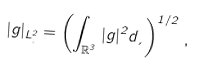Convert formula to latex. <formula><loc_0><loc_0><loc_500><loc_500>| g | _ { L _ { \xi } ^ { 2 } } = \left ( \int _ { { \mathbb { R } } ^ { 3 } } | g | ^ { 2 } d \xi \right ) ^ { 1 / 2 } \, ,</formula> 